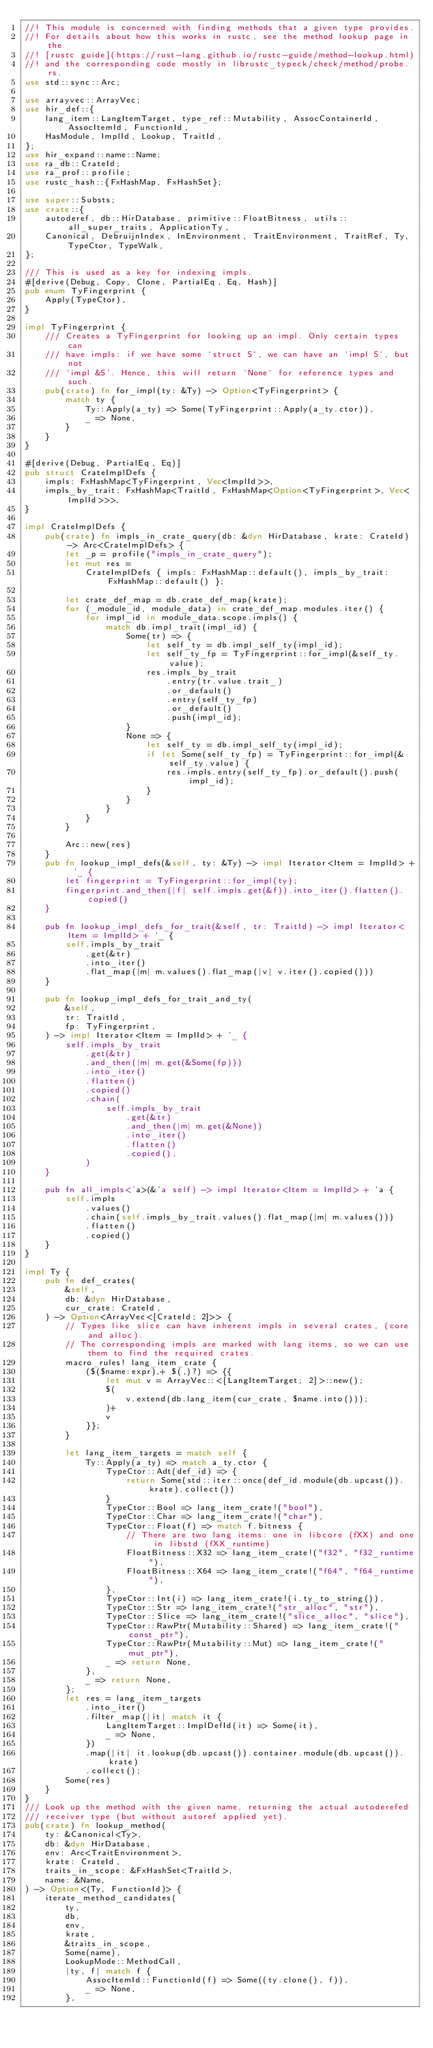<code> <loc_0><loc_0><loc_500><loc_500><_Rust_>//! This module is concerned with finding methods that a given type provides.
//! For details about how this works in rustc, see the method lookup page in the
//! [rustc guide](https://rust-lang.github.io/rustc-guide/method-lookup.html)
//! and the corresponding code mostly in librustc_typeck/check/method/probe.rs.
use std::sync::Arc;

use arrayvec::ArrayVec;
use hir_def::{
    lang_item::LangItemTarget, type_ref::Mutability, AssocContainerId, AssocItemId, FunctionId,
    HasModule, ImplId, Lookup, TraitId,
};
use hir_expand::name::Name;
use ra_db::CrateId;
use ra_prof::profile;
use rustc_hash::{FxHashMap, FxHashSet};

use super::Substs;
use crate::{
    autoderef, db::HirDatabase, primitive::FloatBitness, utils::all_super_traits, ApplicationTy,
    Canonical, DebruijnIndex, InEnvironment, TraitEnvironment, TraitRef, Ty, TypeCtor, TypeWalk,
};

/// This is used as a key for indexing impls.
#[derive(Debug, Copy, Clone, PartialEq, Eq, Hash)]
pub enum TyFingerprint {
    Apply(TypeCtor),
}

impl TyFingerprint {
    /// Creates a TyFingerprint for looking up an impl. Only certain types can
    /// have impls: if we have some `struct S`, we can have an `impl S`, but not
    /// `impl &S`. Hence, this will return `None` for reference types and such.
    pub(crate) fn for_impl(ty: &Ty) -> Option<TyFingerprint> {
        match ty {
            Ty::Apply(a_ty) => Some(TyFingerprint::Apply(a_ty.ctor)),
            _ => None,
        }
    }
}

#[derive(Debug, PartialEq, Eq)]
pub struct CrateImplDefs {
    impls: FxHashMap<TyFingerprint, Vec<ImplId>>,
    impls_by_trait: FxHashMap<TraitId, FxHashMap<Option<TyFingerprint>, Vec<ImplId>>>,
}

impl CrateImplDefs {
    pub(crate) fn impls_in_crate_query(db: &dyn HirDatabase, krate: CrateId) -> Arc<CrateImplDefs> {
        let _p = profile("impls_in_crate_query");
        let mut res =
            CrateImplDefs { impls: FxHashMap::default(), impls_by_trait: FxHashMap::default() };

        let crate_def_map = db.crate_def_map(krate);
        for (_module_id, module_data) in crate_def_map.modules.iter() {
            for impl_id in module_data.scope.impls() {
                match db.impl_trait(impl_id) {
                    Some(tr) => {
                        let self_ty = db.impl_self_ty(impl_id);
                        let self_ty_fp = TyFingerprint::for_impl(&self_ty.value);
                        res.impls_by_trait
                            .entry(tr.value.trait_)
                            .or_default()
                            .entry(self_ty_fp)
                            .or_default()
                            .push(impl_id);
                    }
                    None => {
                        let self_ty = db.impl_self_ty(impl_id);
                        if let Some(self_ty_fp) = TyFingerprint::for_impl(&self_ty.value) {
                            res.impls.entry(self_ty_fp).or_default().push(impl_id);
                        }
                    }
                }
            }
        }

        Arc::new(res)
    }
    pub fn lookup_impl_defs(&self, ty: &Ty) -> impl Iterator<Item = ImplId> + '_ {
        let fingerprint = TyFingerprint::for_impl(ty);
        fingerprint.and_then(|f| self.impls.get(&f)).into_iter().flatten().copied()
    }

    pub fn lookup_impl_defs_for_trait(&self, tr: TraitId) -> impl Iterator<Item = ImplId> + '_ {
        self.impls_by_trait
            .get(&tr)
            .into_iter()
            .flat_map(|m| m.values().flat_map(|v| v.iter().copied()))
    }

    pub fn lookup_impl_defs_for_trait_and_ty(
        &self,
        tr: TraitId,
        fp: TyFingerprint,
    ) -> impl Iterator<Item = ImplId> + '_ {
        self.impls_by_trait
            .get(&tr)
            .and_then(|m| m.get(&Some(fp)))
            .into_iter()
            .flatten()
            .copied()
            .chain(
                self.impls_by_trait
                    .get(&tr)
                    .and_then(|m| m.get(&None))
                    .into_iter()
                    .flatten()
                    .copied(),
            )
    }

    pub fn all_impls<'a>(&'a self) -> impl Iterator<Item = ImplId> + 'a {
        self.impls
            .values()
            .chain(self.impls_by_trait.values().flat_map(|m| m.values()))
            .flatten()
            .copied()
    }
}

impl Ty {
    pub fn def_crates(
        &self,
        db: &dyn HirDatabase,
        cur_crate: CrateId,
    ) -> Option<ArrayVec<[CrateId; 2]>> {
        // Types like slice can have inherent impls in several crates, (core and alloc).
        // The corresponding impls are marked with lang items, so we can use them to find the required crates.
        macro_rules! lang_item_crate {
            ($($name:expr),+ $(,)?) => {{
                let mut v = ArrayVec::<[LangItemTarget; 2]>::new();
                $(
                    v.extend(db.lang_item(cur_crate, $name.into()));
                )+
                v
            }};
        }

        let lang_item_targets = match self {
            Ty::Apply(a_ty) => match a_ty.ctor {
                TypeCtor::Adt(def_id) => {
                    return Some(std::iter::once(def_id.module(db.upcast()).krate).collect())
                }
                TypeCtor::Bool => lang_item_crate!("bool"),
                TypeCtor::Char => lang_item_crate!("char"),
                TypeCtor::Float(f) => match f.bitness {
                    // There are two lang items: one in libcore (fXX) and one in libstd (fXX_runtime)
                    FloatBitness::X32 => lang_item_crate!("f32", "f32_runtime"),
                    FloatBitness::X64 => lang_item_crate!("f64", "f64_runtime"),
                },
                TypeCtor::Int(i) => lang_item_crate!(i.ty_to_string()),
                TypeCtor::Str => lang_item_crate!("str_alloc", "str"),
                TypeCtor::Slice => lang_item_crate!("slice_alloc", "slice"),
                TypeCtor::RawPtr(Mutability::Shared) => lang_item_crate!("const_ptr"),
                TypeCtor::RawPtr(Mutability::Mut) => lang_item_crate!("mut_ptr"),
                _ => return None,
            },
            _ => return None,
        };
        let res = lang_item_targets
            .into_iter()
            .filter_map(|it| match it {
                LangItemTarget::ImplDefId(it) => Some(it),
                _ => None,
            })
            .map(|it| it.lookup(db.upcast()).container.module(db.upcast()).krate)
            .collect();
        Some(res)
    }
}
/// Look up the method with the given name, returning the actual autoderefed
/// receiver type (but without autoref applied yet).
pub(crate) fn lookup_method(
    ty: &Canonical<Ty>,
    db: &dyn HirDatabase,
    env: Arc<TraitEnvironment>,
    krate: CrateId,
    traits_in_scope: &FxHashSet<TraitId>,
    name: &Name,
) -> Option<(Ty, FunctionId)> {
    iterate_method_candidates(
        ty,
        db,
        env,
        krate,
        &traits_in_scope,
        Some(name),
        LookupMode::MethodCall,
        |ty, f| match f {
            AssocItemId::FunctionId(f) => Some((ty.clone(), f)),
            _ => None,
        },</code> 